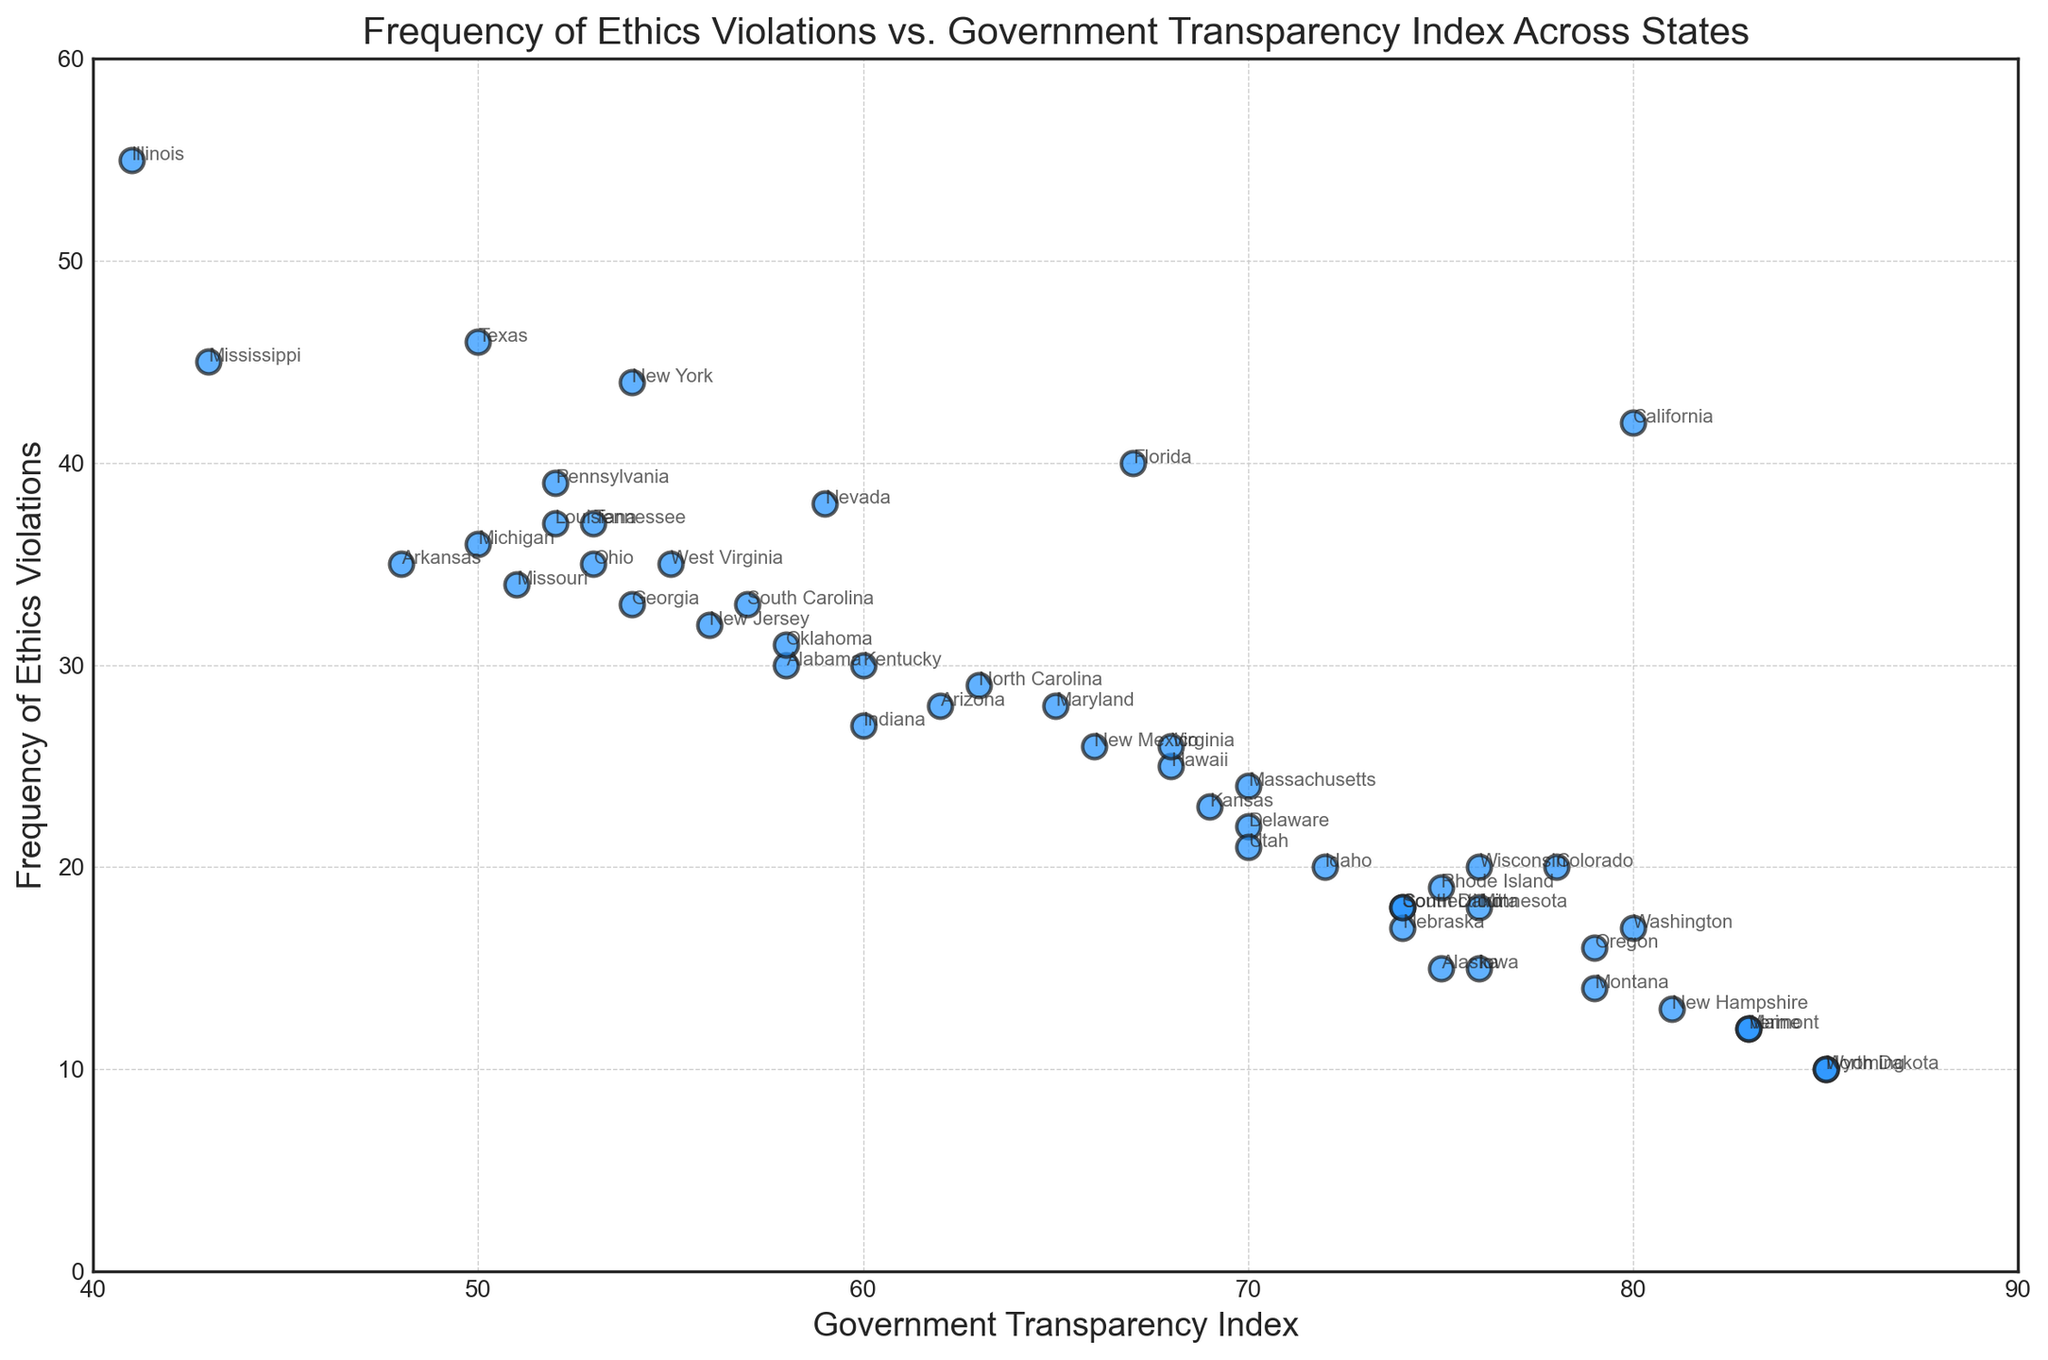Which state has the highest frequency of ethics violations? By looking at the scatter plot, we can identify the point on the y-axis (Frequency of Ethics Violations) that reaches the highest value. The state label closest to this point will be the one with the highest frequency of ethics violations.
Answer: Illinois What is the relationship between the Government Transparency Index and the frequency of ethics violations for the state with the highest transparency? First, identify the state with the highest Government Transparency Index by checking the x-axis. Then, check the corresponding y-value (frequency of ethics violations) for that state.
Answer: North Dakota, 10 violations Which state is an outlier with both high transparency and low ethics violations? Find the state that has both a high transparency index (towards the right of the x-axis) and a low frequency of ethics violations (towards the bottom of the y-axis).
Answer: Wyoming How many states have more than 30 ethics violations? Count the number of points above the y-value of 30, regardless of their x-axis position.
Answer: 11 states Is there a general trend between government transparency and ethics violations across states? Observe the overall distribution of points in the scatter plot. If points tend to show an upward or downward trend, this indicates a general relationship.
Answer: Generally, states with lower transparency (left side) have more violations Which states have a transparency index of 70 and what are their corresponding ethics violation frequencies? Locate the points on the scatter plot where the x-axis value is 70 and note the corresponding y-axis values. Identify the state labels attached to those points.
Answer: Delaware (22), Massachusetts (24), Utah (21), Virginia (26) Which state with a transparency index of 50 has the highest frequency of ethics violations? Identify the data points on the x-axis at 50 and compare their y-axis values to find the highest one.
Answer: Texas (46 violations) What is the median frequency of ethics violations for states with a transparency index above 75? First, list all the y-values (ethics violations) for points with an x-value above 75. Then, find the median of these values.
Answer: 17.5 Compare the ethics violation frequencies of California and Florida. Locate the points on the scatter plot labeled California and Florida, and compare their y-values (ethics violations).
Answer: California (42), Florida (40) Which state labeled on the scatter plot has the closest ethics violation frequency to the national average? Calculate the average frequency of ethics violations for all states represented on the plot by summing their y-values and dividing by the number of states. Then, identify the state whose y-value (ethics violations) is closest to this average.
Answer: Oklahoma 